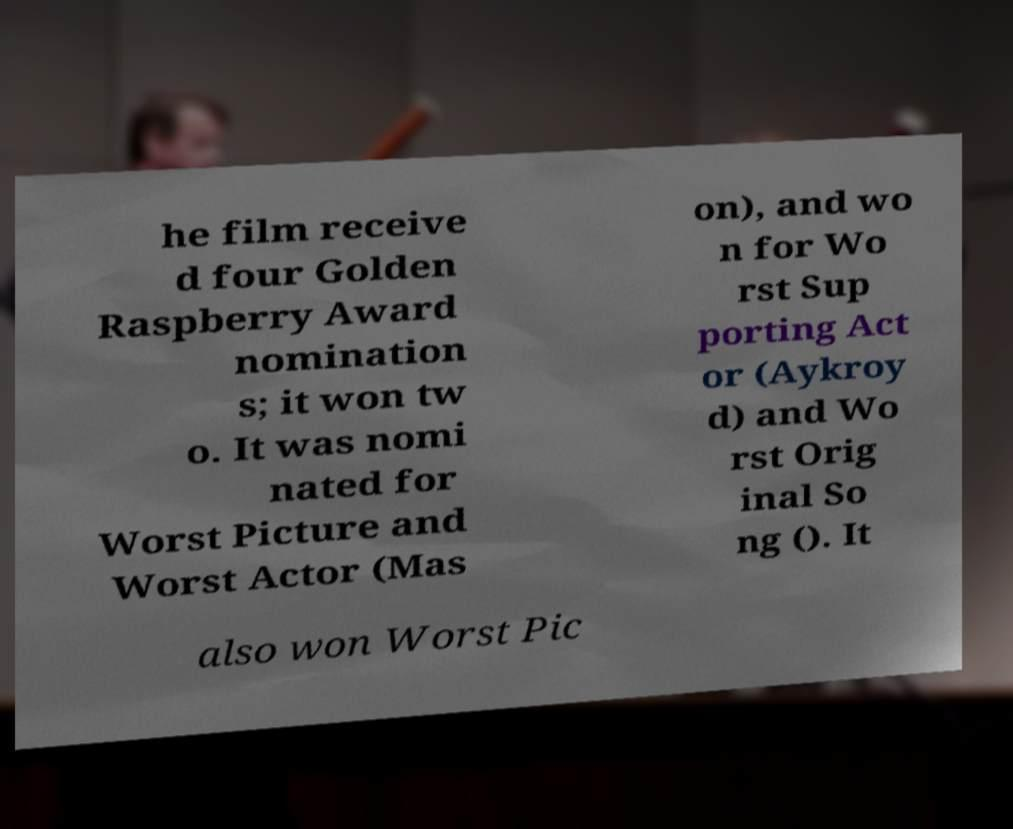I need the written content from this picture converted into text. Can you do that? he film receive d four Golden Raspberry Award nomination s; it won tw o. It was nomi nated for Worst Picture and Worst Actor (Mas on), and wo n for Wo rst Sup porting Act or (Aykroy d) and Wo rst Orig inal So ng (). It also won Worst Pic 